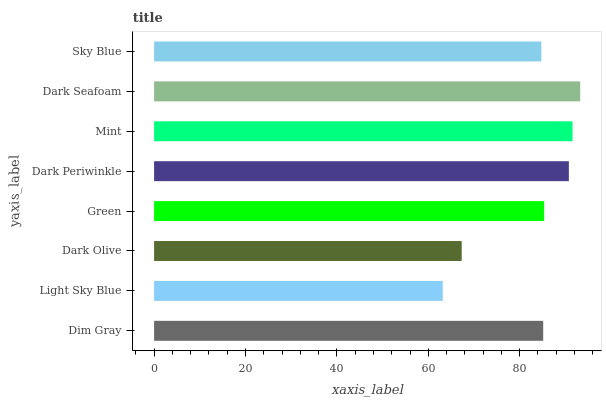Is Light Sky Blue the minimum?
Answer yes or no. Yes. Is Dark Seafoam the maximum?
Answer yes or no. Yes. Is Dark Olive the minimum?
Answer yes or no. No. Is Dark Olive the maximum?
Answer yes or no. No. Is Dark Olive greater than Light Sky Blue?
Answer yes or no. Yes. Is Light Sky Blue less than Dark Olive?
Answer yes or no. Yes. Is Light Sky Blue greater than Dark Olive?
Answer yes or no. No. Is Dark Olive less than Light Sky Blue?
Answer yes or no. No. Is Green the high median?
Answer yes or no. Yes. Is Dim Gray the low median?
Answer yes or no. Yes. Is Dim Gray the high median?
Answer yes or no. No. Is Dark Olive the low median?
Answer yes or no. No. 